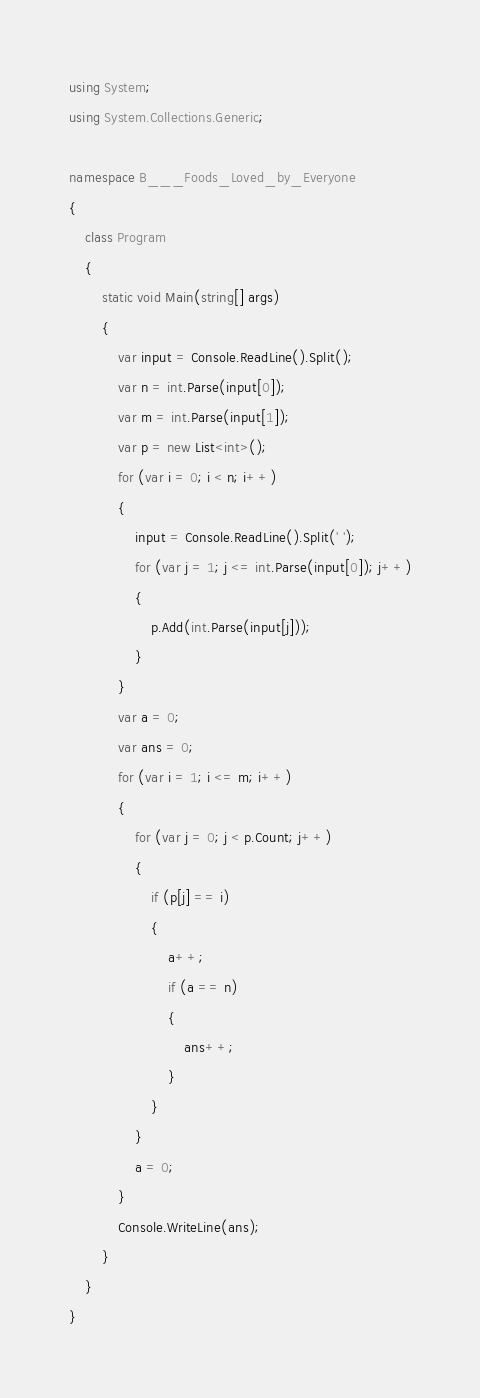<code> <loc_0><loc_0><loc_500><loc_500><_C#_>using System;
using System.Collections.Generic;

namespace B___Foods_Loved_by_Everyone
{
    class Program
    {
        static void Main(string[] args)
        {
            var input = Console.ReadLine().Split();
            var n = int.Parse(input[0]);
            var m = int.Parse(input[1]);
            var p = new List<int>();
            for (var i = 0; i < n; i++)
            {
                input = Console.ReadLine().Split(' ');
                for (var j = 1; j <= int.Parse(input[0]); j++)
                {
                    p.Add(int.Parse(input[j]));
                }
            }
            var a = 0;
            var ans = 0;
            for (var i = 1; i <= m; i++)
            {
                for (var j = 0; j < p.Count; j++)
                {
                    if (p[j] == i)
                    {
                        a++;
                        if (a == n)
                        {
                            ans++;
                        }
                    }
                }
                a = 0;
            }
            Console.WriteLine(ans);
        }
    }
}</code> 